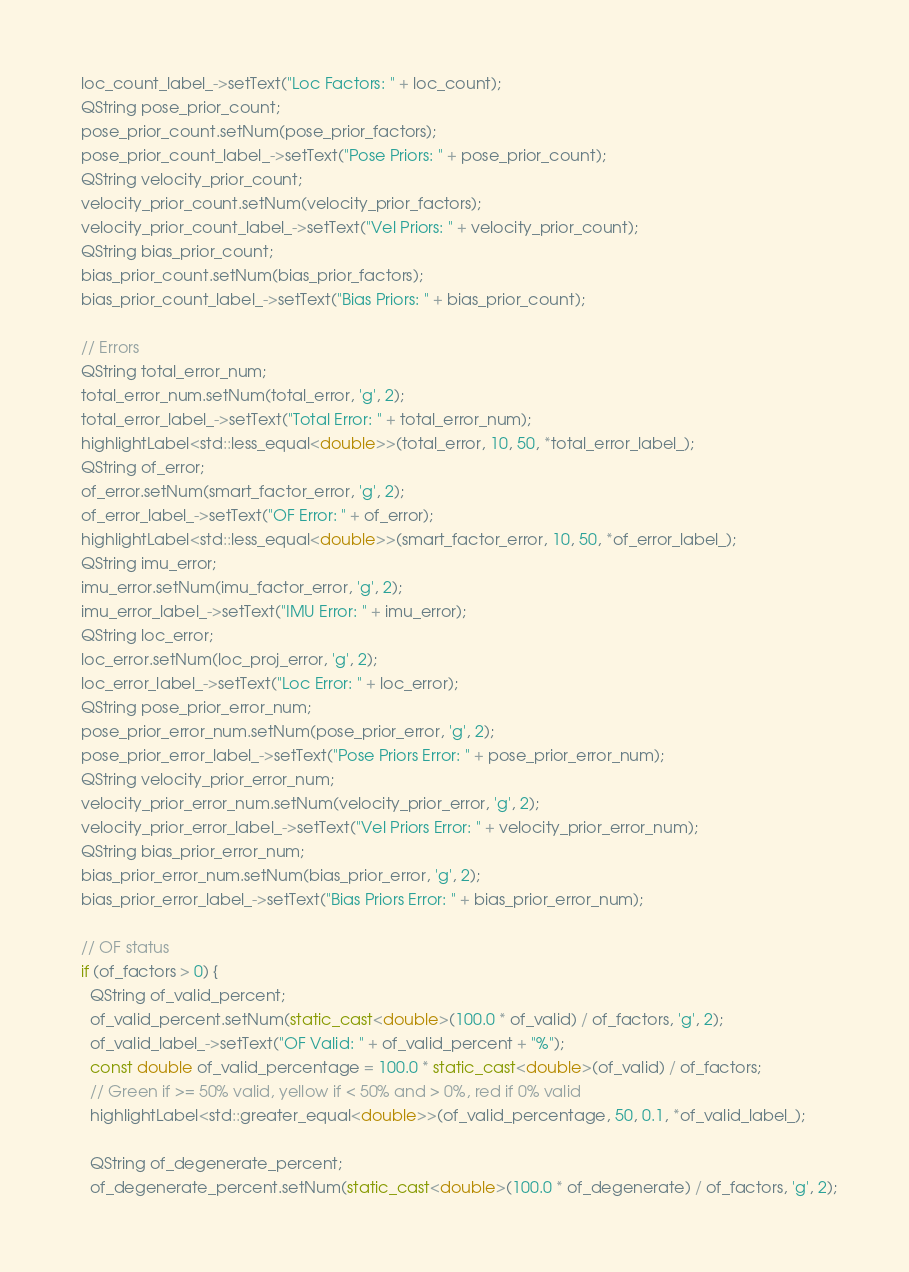Convert code to text. <code><loc_0><loc_0><loc_500><loc_500><_C++_>  loc_count_label_->setText("Loc Factors: " + loc_count);
  QString pose_prior_count;
  pose_prior_count.setNum(pose_prior_factors);
  pose_prior_count_label_->setText("Pose Priors: " + pose_prior_count);
  QString velocity_prior_count;
  velocity_prior_count.setNum(velocity_prior_factors);
  velocity_prior_count_label_->setText("Vel Priors: " + velocity_prior_count);
  QString bias_prior_count;
  bias_prior_count.setNum(bias_prior_factors);
  bias_prior_count_label_->setText("Bias Priors: " + bias_prior_count);

  // Errors
  QString total_error_num;
  total_error_num.setNum(total_error, 'g', 2);
  total_error_label_->setText("Total Error: " + total_error_num);
  highlightLabel<std::less_equal<double>>(total_error, 10, 50, *total_error_label_);
  QString of_error;
  of_error.setNum(smart_factor_error, 'g', 2);
  of_error_label_->setText("OF Error: " + of_error);
  highlightLabel<std::less_equal<double>>(smart_factor_error, 10, 50, *of_error_label_);
  QString imu_error;
  imu_error.setNum(imu_factor_error, 'g', 2);
  imu_error_label_->setText("IMU Error: " + imu_error);
  QString loc_error;
  loc_error.setNum(loc_proj_error, 'g', 2);
  loc_error_label_->setText("Loc Error: " + loc_error);
  QString pose_prior_error_num;
  pose_prior_error_num.setNum(pose_prior_error, 'g', 2);
  pose_prior_error_label_->setText("Pose Priors Error: " + pose_prior_error_num);
  QString velocity_prior_error_num;
  velocity_prior_error_num.setNum(velocity_prior_error, 'g', 2);
  velocity_prior_error_label_->setText("Vel Priors Error: " + velocity_prior_error_num);
  QString bias_prior_error_num;
  bias_prior_error_num.setNum(bias_prior_error, 'g', 2);
  bias_prior_error_label_->setText("Bias Priors Error: " + bias_prior_error_num);

  // OF status
  if (of_factors > 0) {
    QString of_valid_percent;
    of_valid_percent.setNum(static_cast<double>(100.0 * of_valid) / of_factors, 'g', 2);
    of_valid_label_->setText("OF Valid: " + of_valid_percent + "%");
    const double of_valid_percentage = 100.0 * static_cast<double>(of_valid) / of_factors;
    // Green if >= 50% valid, yellow if < 50% and > 0%, red if 0% valid
    highlightLabel<std::greater_equal<double>>(of_valid_percentage, 50, 0.1, *of_valid_label_);

    QString of_degenerate_percent;
    of_degenerate_percent.setNum(static_cast<double>(100.0 * of_degenerate) / of_factors, 'g', 2);</code> 